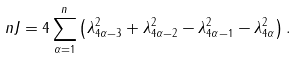Convert formula to latex. <formula><loc_0><loc_0><loc_500><loc_500>\ n J = 4 \sum _ { \alpha = 1 } ^ { n } \left ( \lambda _ { 4 \alpha - 3 } ^ { 2 } + \lambda _ { 4 \alpha - 2 } ^ { 2 } - \lambda _ { 4 \alpha - 1 } ^ { 2 } - \lambda _ { 4 \alpha } ^ { 2 } \right ) .</formula> 